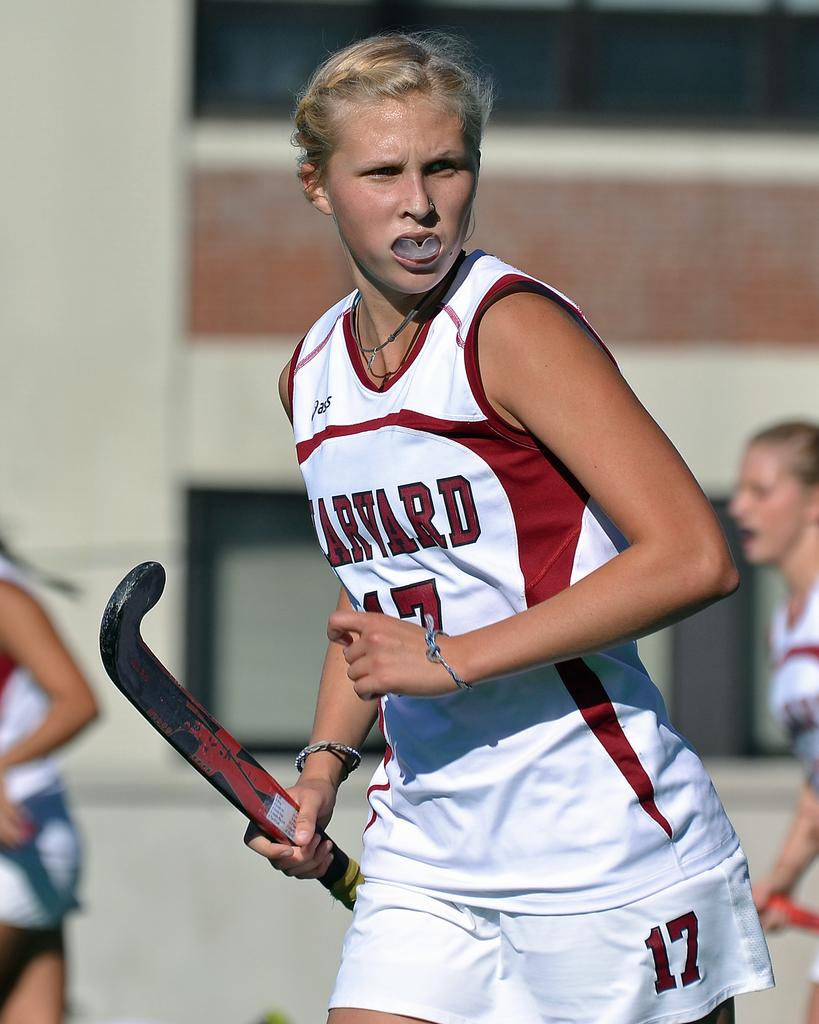<image>
Give a short and clear explanation of the subsequent image. female harvard player number 17 looking off to the side 